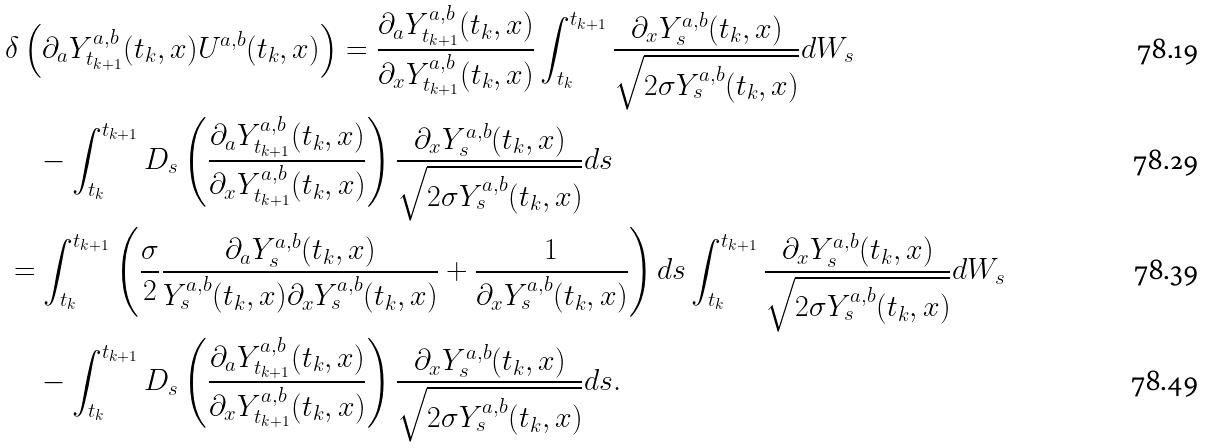Convert formula to latex. <formula><loc_0><loc_0><loc_500><loc_500>& \delta \left ( \partial _ { a } Y _ { t _ { k + 1 } } ^ { a , b } ( t _ { k } , x ) U ^ { a , b } ( t _ { k } , x ) \right ) = \frac { \partial _ { a } Y _ { t _ { k + 1 } } ^ { a , b } ( t _ { k } , x ) } { \partial _ { x } Y _ { t _ { k + 1 } } ^ { a , b } ( t _ { k } , x ) } \int _ { t _ { k } } ^ { t _ { k + 1 } } \frac { \partial _ { x } Y _ { s } ^ { a , b } ( t _ { k } , x ) } { \sqrt { 2 \sigma Y _ { s } ^ { a , b } ( t _ { k } , x ) } } d W _ { s } \\ & \quad - \int _ { t _ { k } } ^ { t _ { k + 1 } } D _ { s } \left ( \frac { \partial _ { a } Y _ { t _ { k + 1 } } ^ { a , b } ( t _ { k } , x ) } { \partial _ { x } Y _ { t _ { k + 1 } } ^ { a , b } ( t _ { k } , x ) } \right ) \frac { \partial _ { x } Y _ { s } ^ { a , b } ( t _ { k } , x ) } { \sqrt { 2 \sigma Y _ { s } ^ { a , b } ( t _ { k } , x ) } } d s \\ & = \int _ { t _ { k } } ^ { t _ { k + 1 } } \left ( \frac { \sigma } { 2 } \frac { \partial _ { a } Y _ { s } ^ { a , b } ( t _ { k } , x ) } { Y _ { s } ^ { a , b } ( t _ { k } , x ) \partial _ { x } Y _ { s } ^ { a , b } ( t _ { k } , x ) } + \frac { 1 } { \partial _ { x } Y _ { s } ^ { a , b } ( t _ { k } , x ) } \right ) d s \int _ { t _ { k } } ^ { t _ { k + 1 } } \frac { \partial _ { x } Y _ { s } ^ { a , b } ( t _ { k } , x ) } { \sqrt { 2 \sigma Y _ { s } ^ { a , b } ( t _ { k } , x ) } } d W _ { s } \\ & \quad - \int _ { t _ { k } } ^ { t _ { k + 1 } } D _ { s } \left ( \frac { \partial _ { a } Y _ { t _ { k + 1 } } ^ { a , b } ( t _ { k } , x ) } { \partial _ { x } Y _ { t _ { k + 1 } } ^ { a , b } ( t _ { k } , x ) } \right ) \frac { \partial _ { x } Y _ { s } ^ { a , b } ( t _ { k } , x ) } { \sqrt { 2 \sigma Y _ { s } ^ { a , b } ( t _ { k } , x ) } } d s .</formula> 